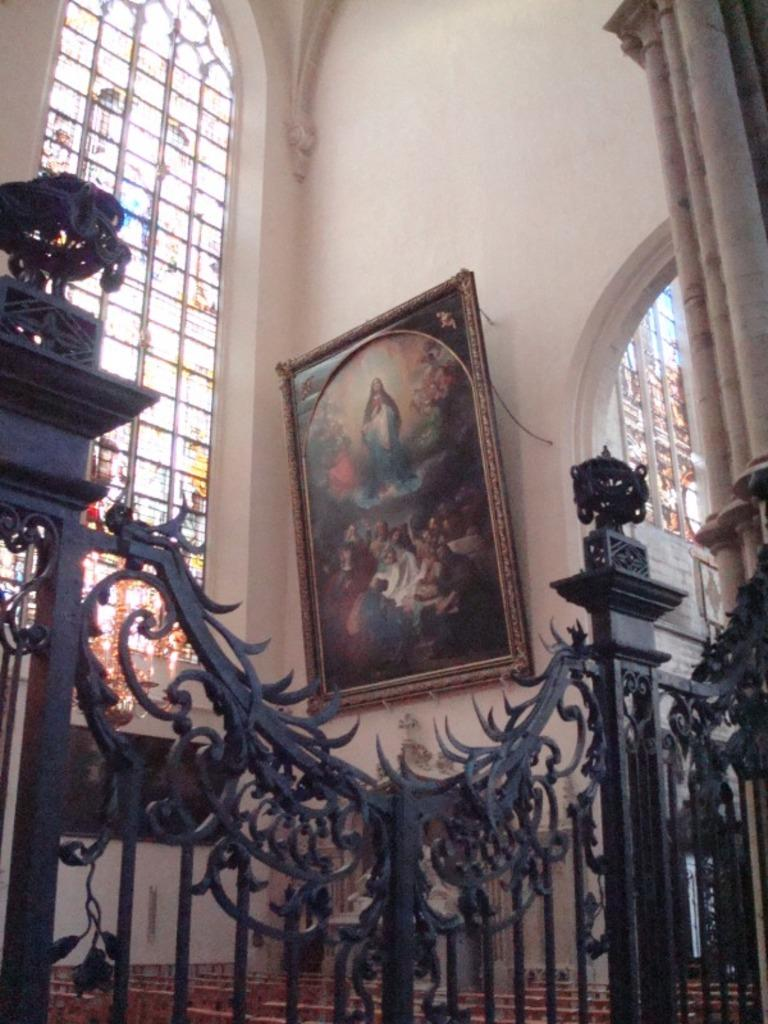What is the main structure visible in the image? There is a wall with a frame in the image. What architectural features can be seen in the image? There are windows and a fence visible in the image. What type of objects are present in the image? There are objects in the image, but their specific nature is not mentioned in the facts. Can you describe any other structural elements in the image? There is a pillar in the image. How many cars are parked near the fence in the image? There is no mention of cars in the image, so it is not possible to answer this question. 